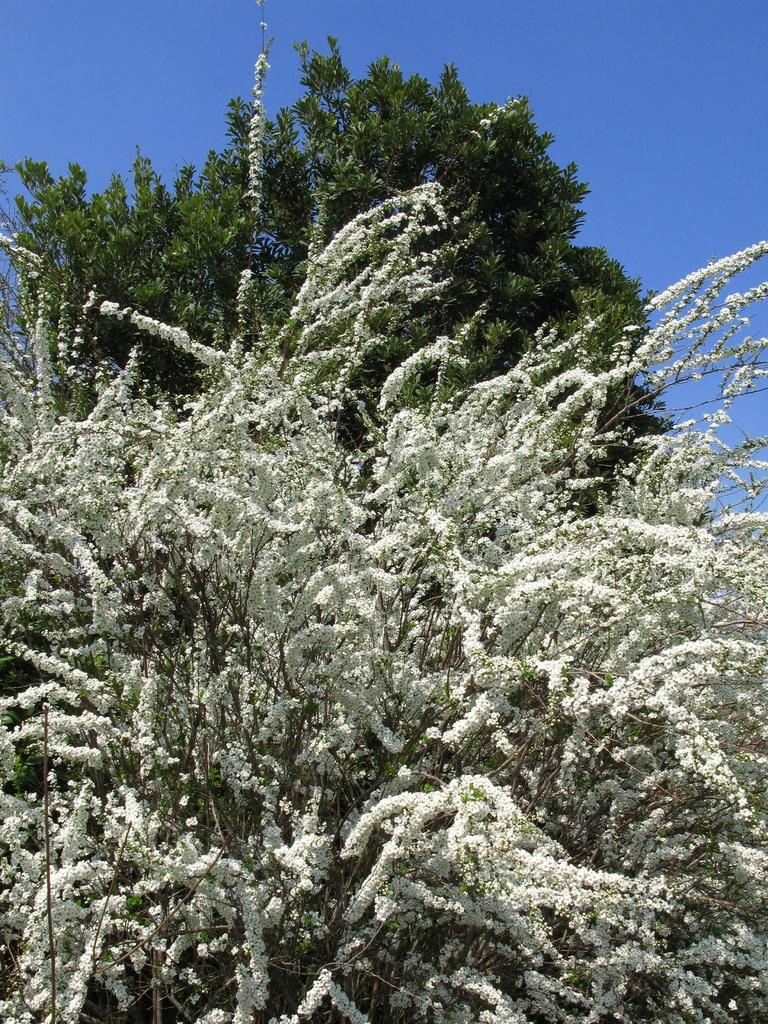What type of vegetation can be seen in the image? There are trees in the image. What part of the natural environment is visible in the image? The sky is visible in the background of the image. How many flocks of birds can be seen flying over the road in the image? There is no road or flock of birds present in the image; it features trees and the sky. 